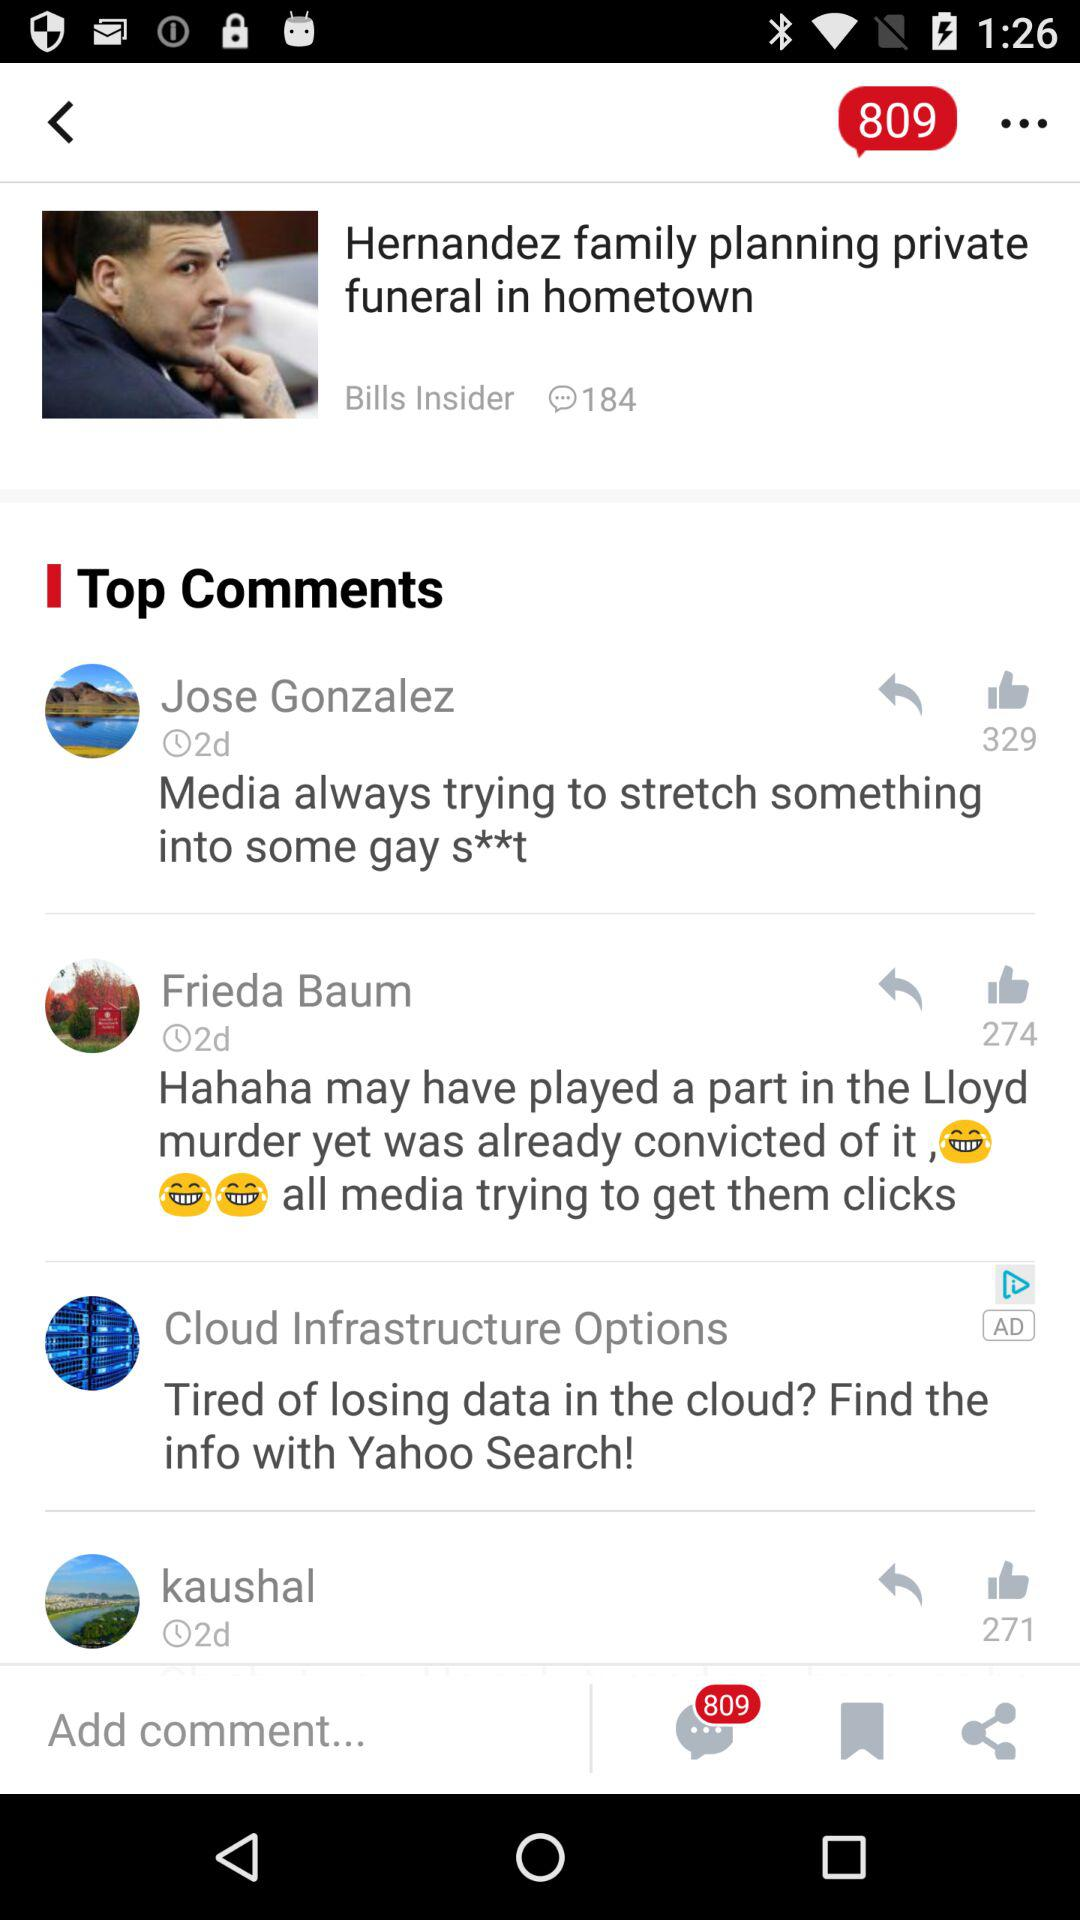How many likes are there of Jose's comment? There are 329 likes of Jose's comment. 